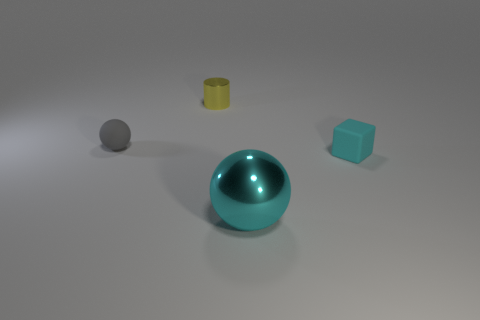Add 3 tiny cyan blocks. How many objects exist? 7 Subtract all cylinders. How many objects are left? 3 Subtract all big green cubes. Subtract all tiny yellow objects. How many objects are left? 3 Add 2 big cyan things. How many big cyan things are left? 3 Add 1 big metal objects. How many big metal objects exist? 2 Subtract 0 green cubes. How many objects are left? 4 